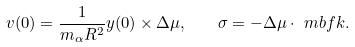<formula> <loc_0><loc_0><loc_500><loc_500>v ( 0 ) = \frac { 1 } { m _ { \alpha } R ^ { 2 } } y ( 0 ) \times \Delta \mu , \quad \sigma = - \Delta \mu \cdot \ m b f k .</formula> 